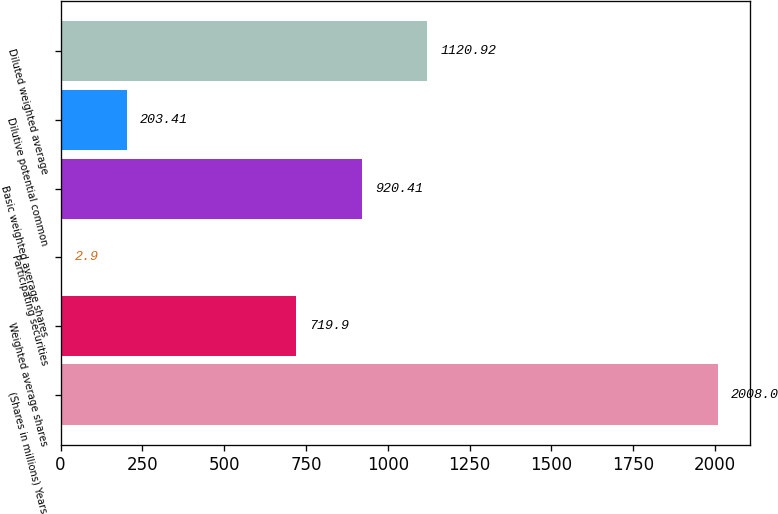Convert chart to OTSL. <chart><loc_0><loc_0><loc_500><loc_500><bar_chart><fcel>(Shares in millions) Years<fcel>Weighted average shares<fcel>Participating securities<fcel>Basic weighted average shares<fcel>Dilutive potential common<fcel>Diluted weighted average<nl><fcel>2008<fcel>719.9<fcel>2.9<fcel>920.41<fcel>203.41<fcel>1120.92<nl></chart> 